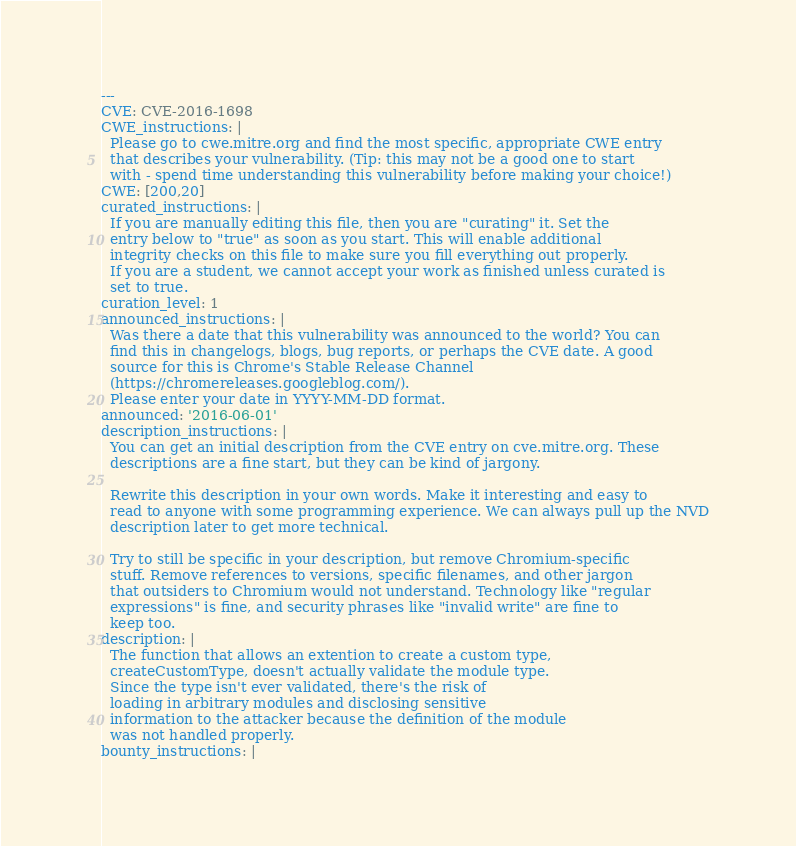Convert code to text. <code><loc_0><loc_0><loc_500><loc_500><_YAML_>---
CVE: CVE-2016-1698
CWE_instructions: |
  Please go to cwe.mitre.org and find the most specific, appropriate CWE entry
  that describes your vulnerability. (Tip: this may not be a good one to start
  with - spend time understanding this vulnerability before making your choice!)
CWE: [200,20]
curated_instructions: |
  If you are manually editing this file, then you are "curating" it. Set the
  entry below to "true" as soon as you start. This will enable additional
  integrity checks on this file to make sure you fill everything out properly.
  If you are a student, we cannot accept your work as finished unless curated is
  set to true.
curation_level: 1
announced_instructions: |
  Was there a date that this vulnerability was announced to the world? You can
  find this in changelogs, blogs, bug reports, or perhaps the CVE date. A good
  source for this is Chrome's Stable Release Channel
  (https://chromereleases.googleblog.com/).
  Please enter your date in YYYY-MM-DD format.
announced: '2016-06-01'
description_instructions: |
  You can get an initial description from the CVE entry on cve.mitre.org. These
  descriptions are a fine start, but they can be kind of jargony.

  Rewrite this description in your own words. Make it interesting and easy to
  read to anyone with some programming experience. We can always pull up the NVD
  description later to get more technical.

  Try to still be specific in your description, but remove Chromium-specific
  stuff. Remove references to versions, specific filenames, and other jargon
  that outsiders to Chromium would not understand. Technology like "regular
  expressions" is fine, and security phrases like "invalid write" are fine to
  keep too.
description: |
  The function that allows an extention to create a custom type,
  createCustomType, doesn't actually validate the module type. 
  Since the type isn't ever validated, there's the risk of 
  loading in arbitrary modules and disclosing sensitive 
  information to the attacker because the definition of the module
  was not handled properly.
bounty_instructions: |</code> 